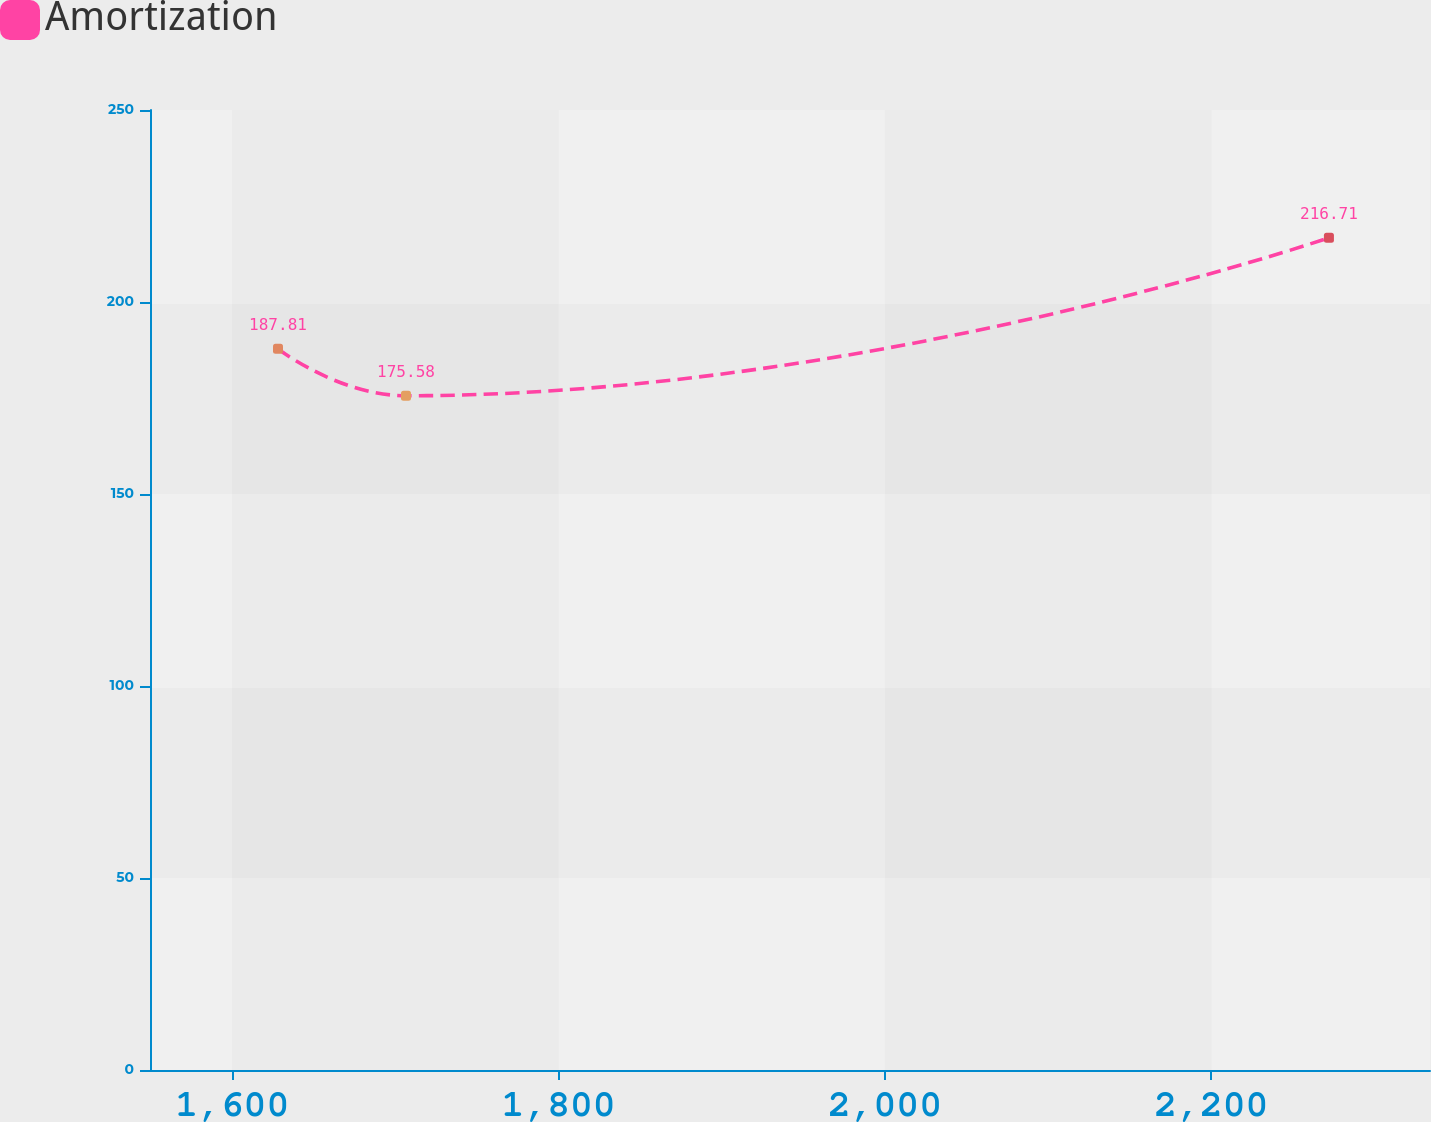Convert chart to OTSL. <chart><loc_0><loc_0><loc_500><loc_500><line_chart><ecel><fcel>Amortization<nl><fcel>1628.07<fcel>187.81<nl><fcel>1706.5<fcel>175.58<nl><fcel>2272.04<fcel>216.71<nl><fcel>2412.41<fcel>94.45<nl></chart> 